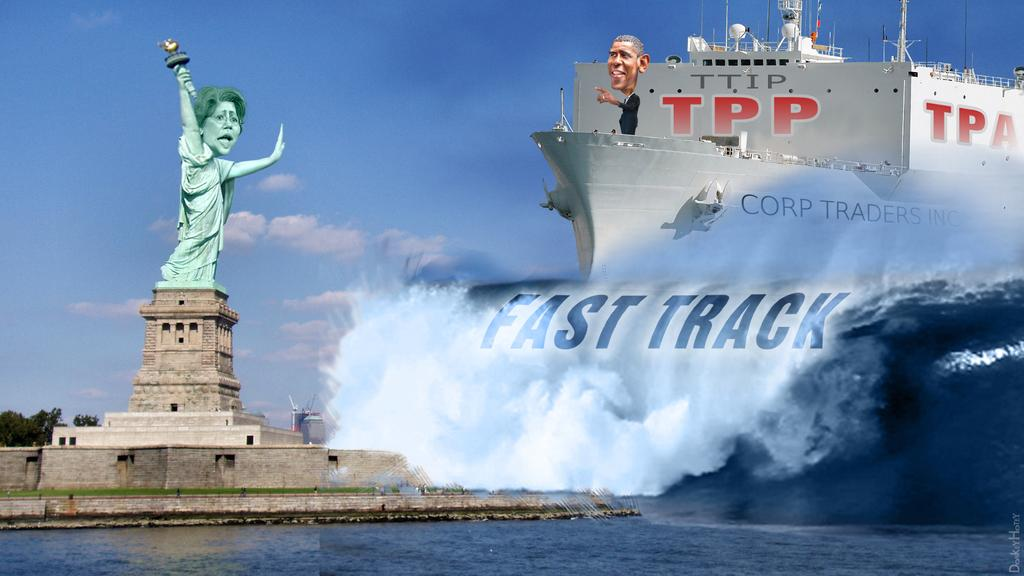What is the main subject in the image? There is a statue in the image. What type of ground is visible in the image? The ground in the image has grass. What other natural elements can be seen in the image? There are trees in the image. What is the water feature in the image? There is a ship in the water in the image. Can you describe the water in the image? There is water visible in the image. What else is present in the image besides the statue, trees, and water? There is text in the image. What can be seen in the sky in the image? The sky is visible in the image, and clouds are present. Where is the stove located in the image? There is no stove present in the image. What type of amusement can be seen in the image? There is no amusement depicted in the image; it features a statue, trees, water, and text. Can you describe the curve of the ship in the image? There is no curve mentioned in the provided facts, and the image does not show a ship with a curve. 